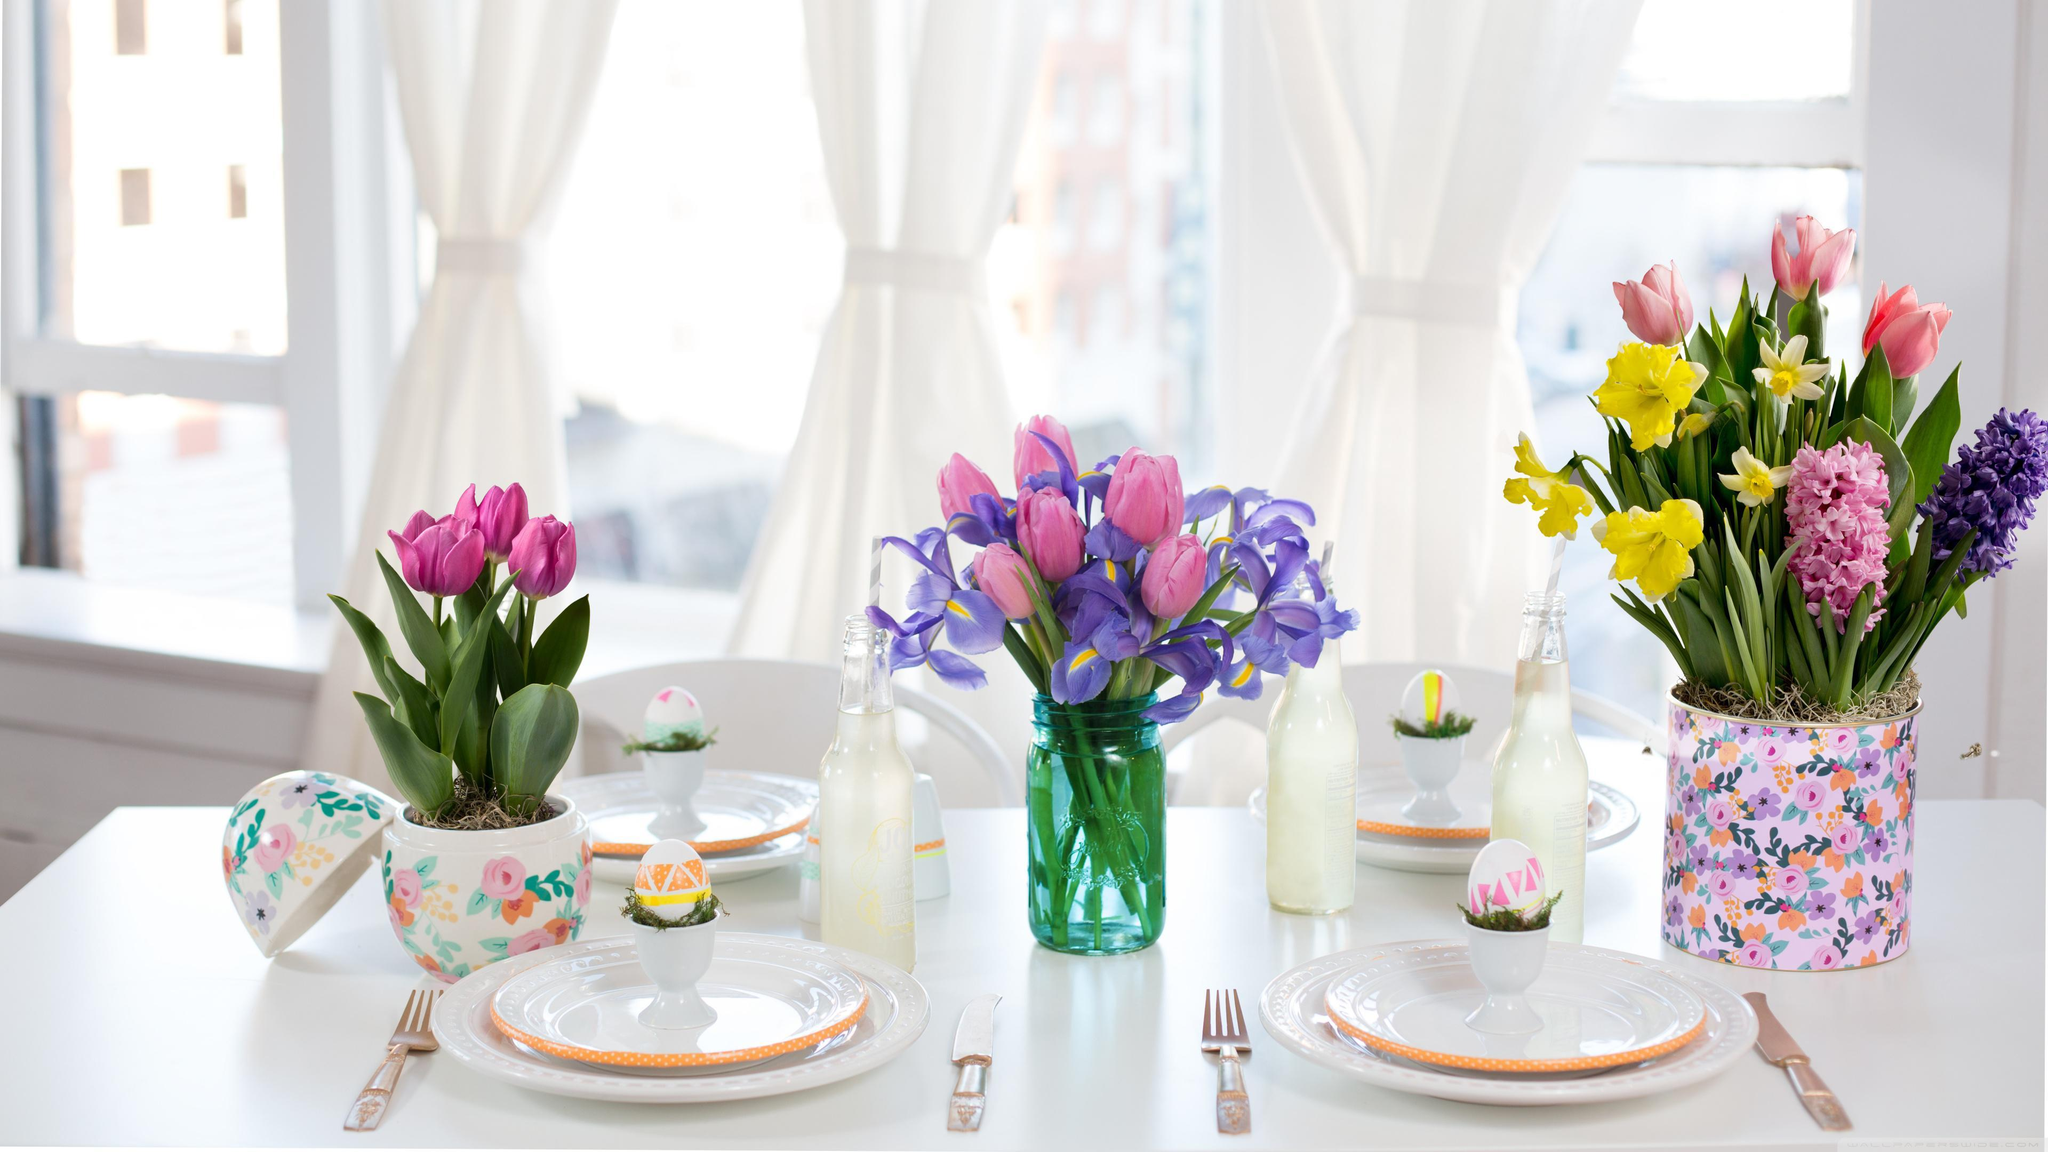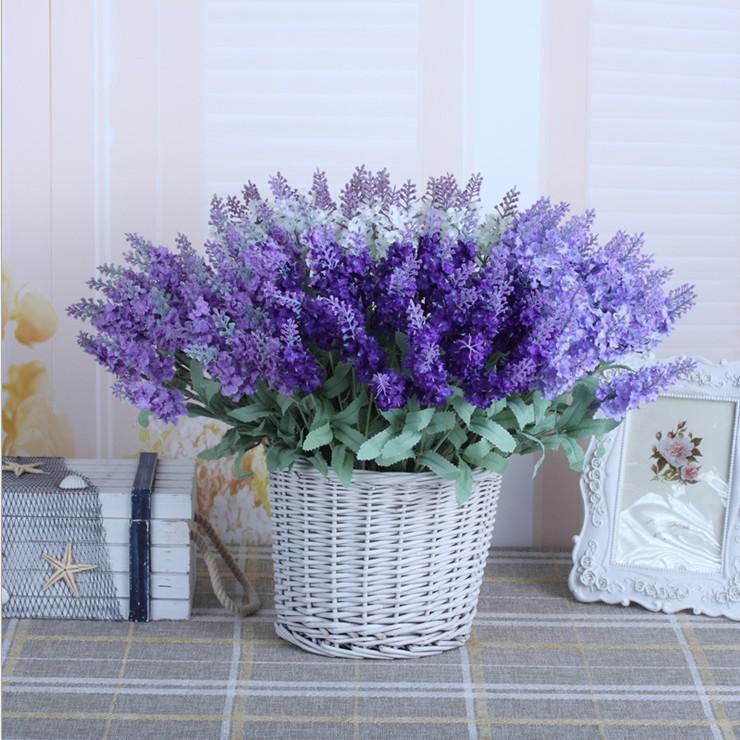The first image is the image on the left, the second image is the image on the right. Considering the images on both sides, is "There are books with the flowers." valid? Answer yes or no. No. The first image is the image on the left, the second image is the image on the right. For the images shown, is this caption "Each image contains exactly one vase of flowers, and the vase in one image contains multiple flower colors, while the other contains flowers with a single petal color." true? Answer yes or no. No. 